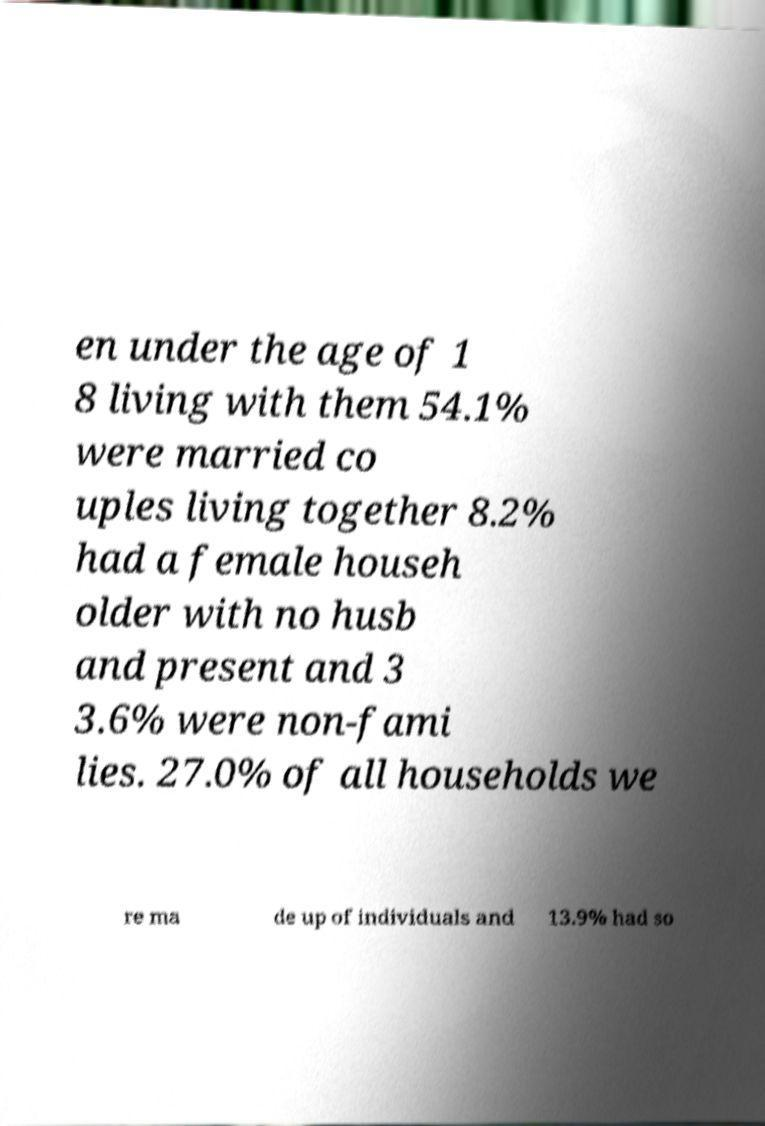There's text embedded in this image that I need extracted. Can you transcribe it verbatim? en under the age of 1 8 living with them 54.1% were married co uples living together 8.2% had a female househ older with no husb and present and 3 3.6% were non-fami lies. 27.0% of all households we re ma de up of individuals and 13.9% had so 